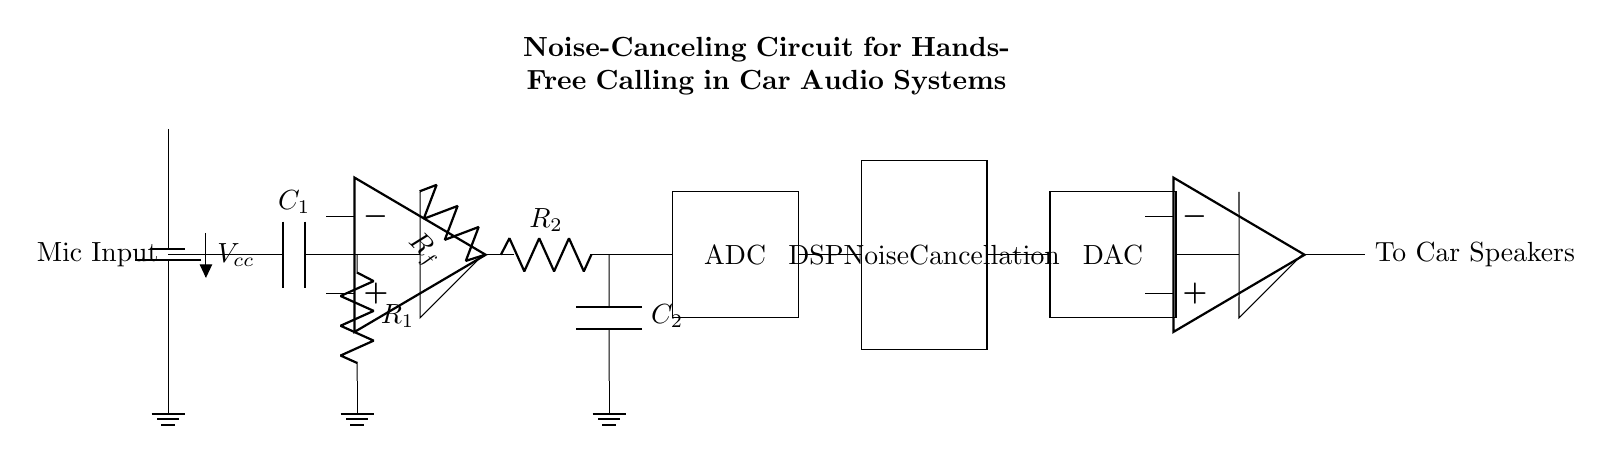What is the type of input for this circuit? The input type is "Mic Input," which is where the microphone signal enters the circuit for processing.
Answer: Mic Input What does the component labeled "ADC" do? The ADC stands for Analog-to-Digital Converter, which converts the analog microphone input signal into a digital signal for processing.
Answer: Converts analog to digital How many operational amplifiers are used in this circuit? There are two operational amplifiers shown in the circuit diagram, one for amplification and another for the output stage.
Answer: Two What is the function of the DSP block in this circuit? The DSP block, which stands for Digital Signal Processor, performs noise cancellation on the digitized signal, enhancing call quality.
Answer: Noise cancellation What is the purpose of the capacitor labeled "C1"? Capacitor C1 serves as a coupling capacitor, allowing AC signals to pass while blocking DC components from the microphone input.
Answer: Coupling AC signals Which components are used to form the low-pass filter? The low-pass filter is formed by resistor R2 and capacitor C2, which together allow low-frequency signals to pass while attenuating high frequencies.
Answer: R2 and C2 What is the output of the circuit connected to? The output of the circuit is connected to "To Car Speakers," indicating that the processed audio signal is sent to the car's audio system.
Answer: To Car Speakers 